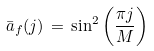<formula> <loc_0><loc_0><loc_500><loc_500>\bar { a } _ { f } ( j ) \, = \, \sin ^ { 2 } \left ( \frac { \pi j } M \right )</formula> 